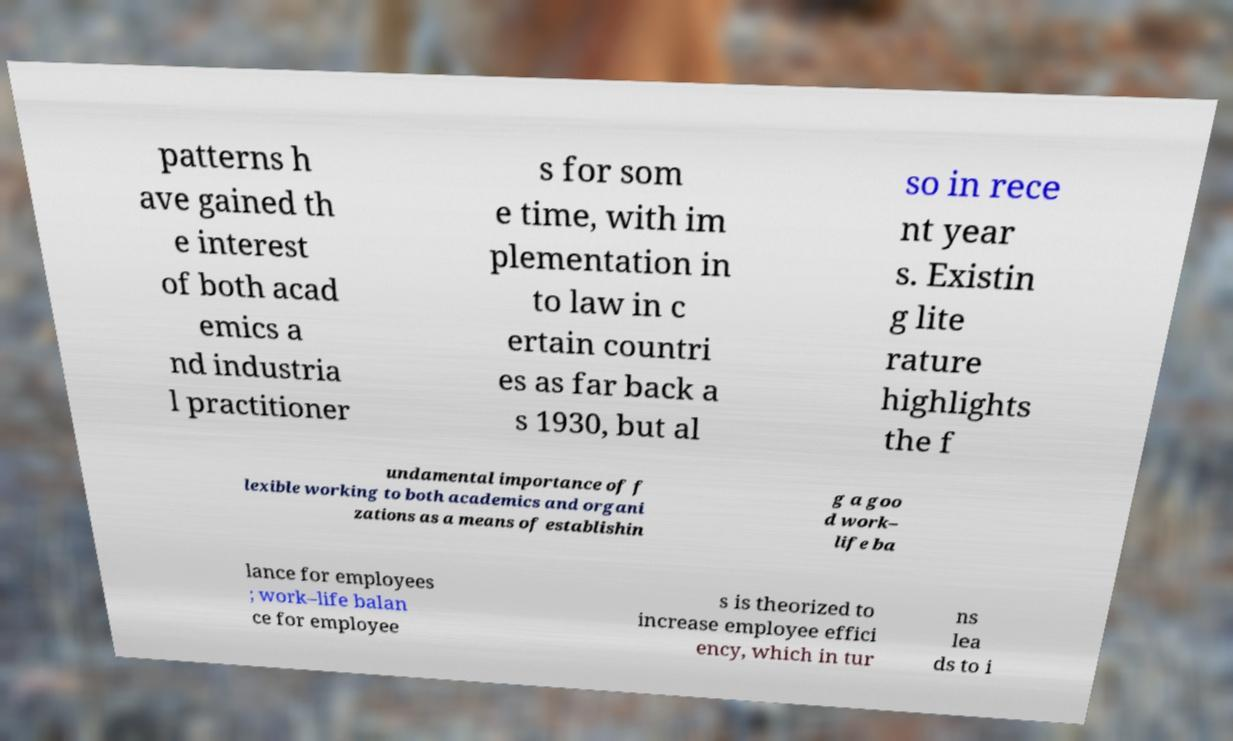Please read and relay the text visible in this image. What does it say? patterns h ave gained th e interest of both acad emics a nd industria l practitioner s for som e time, with im plementation in to law in c ertain countri es as far back a s 1930, but al so in rece nt year s. Existin g lite rature highlights the f undamental importance of f lexible working to both academics and organi zations as a means of establishin g a goo d work– life ba lance for employees ; work–life balan ce for employee s is theorized to increase employee effici ency, which in tur ns lea ds to i 